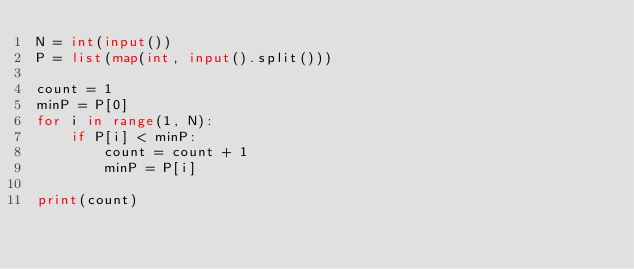<code> <loc_0><loc_0><loc_500><loc_500><_Python_>N = int(input())
P = list(map(int, input().split()))

count = 1
minP = P[0]
for i in range(1, N):
    if P[i] < minP:
        count = count + 1
        minP = P[i]

print(count)</code> 